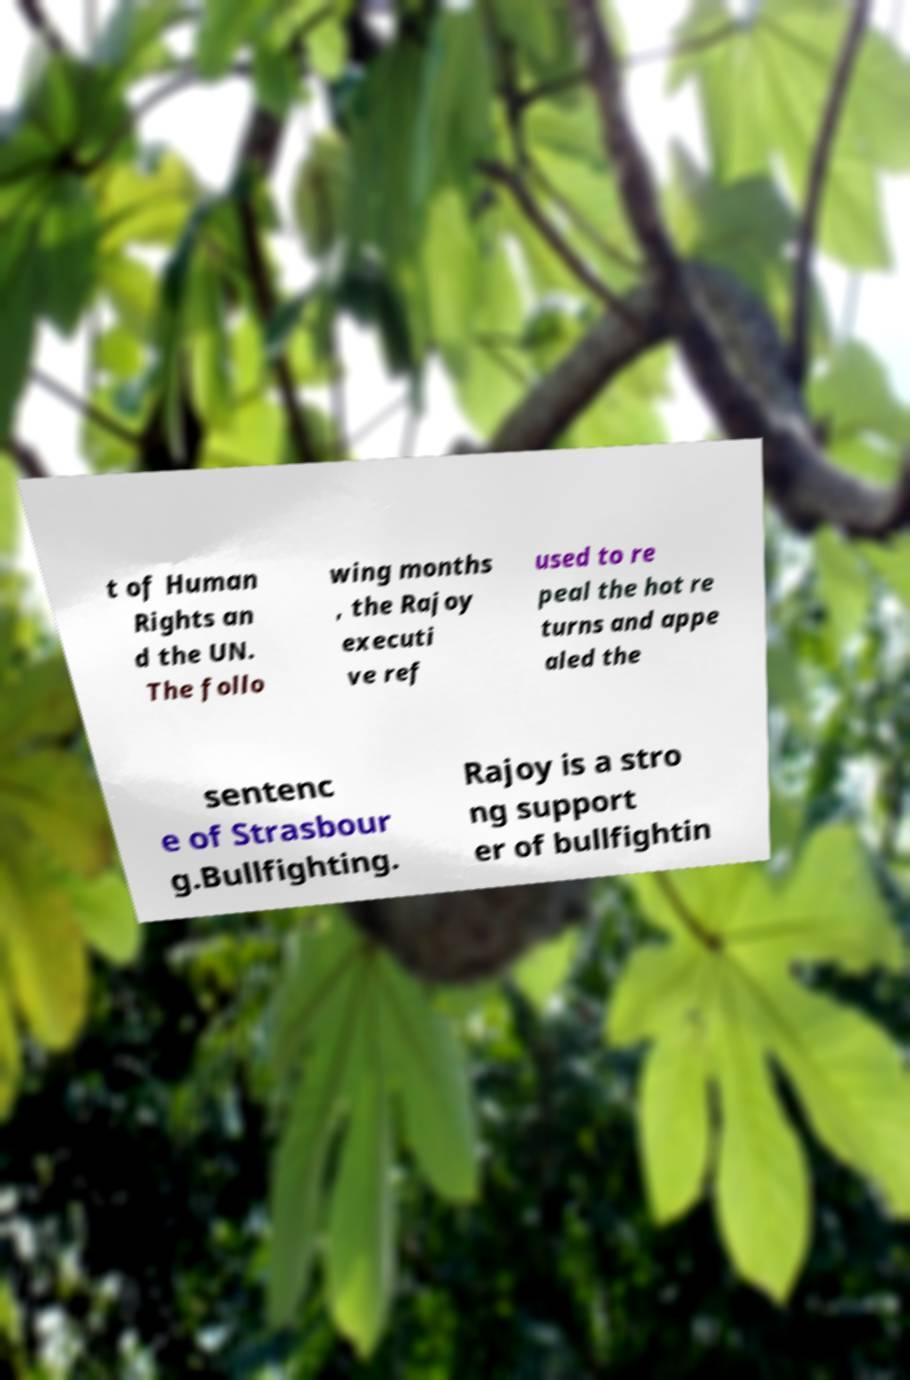I need the written content from this picture converted into text. Can you do that? t of Human Rights an d the UN. The follo wing months , the Rajoy executi ve ref used to re peal the hot re turns and appe aled the sentenc e of Strasbour g.Bullfighting. Rajoy is a stro ng support er of bullfightin 